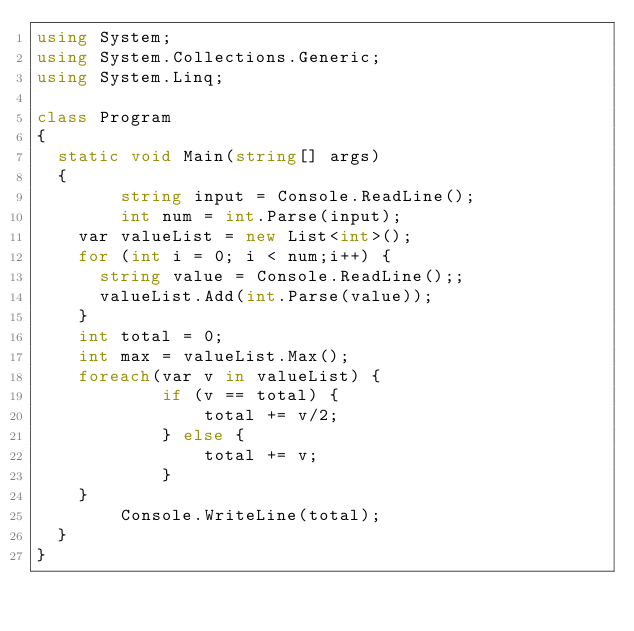Convert code to text. <code><loc_0><loc_0><loc_500><loc_500><_C#_>using System;
using System.Collections.Generic;
using System.Linq;

class Program
{
	static void Main(string[] args)
	{
        string input = Console.ReadLine();
        int num = int.Parse(input);
		var valueList = new List<int>();
		for (int i = 0; i < num;i++) {
			string value = Console.ReadLine();;
			valueList.Add(int.Parse(value));
		}
		int total = 0;
		int max = valueList.Max();
		foreach(var v in valueList) {
            if (v == total) { 
                total += v/2;
            } else {
                total += v;
            }			
		}
        Console.WriteLine(total);
	}
}</code> 